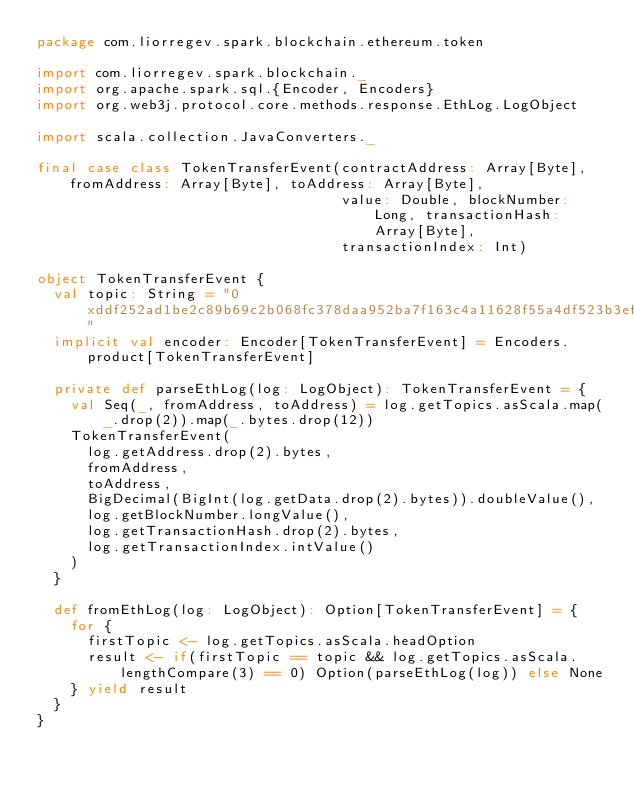<code> <loc_0><loc_0><loc_500><loc_500><_Scala_>package com.liorregev.spark.blockchain.ethereum.token

import com.liorregev.spark.blockchain._
import org.apache.spark.sql.{Encoder, Encoders}
import org.web3j.protocol.core.methods.response.EthLog.LogObject

import scala.collection.JavaConverters._

final case class TokenTransferEvent(contractAddress: Array[Byte], fromAddress: Array[Byte], toAddress: Array[Byte],
                                    value: Double, blockNumber: Long, transactionHash: Array[Byte],
                                    transactionIndex: Int)

object TokenTransferEvent {
  val topic: String = "0xddf252ad1be2c89b69c2b068fc378daa952ba7f163c4a11628f55a4df523b3ef"
  implicit val encoder: Encoder[TokenTransferEvent] = Encoders.product[TokenTransferEvent]

  private def parseEthLog(log: LogObject): TokenTransferEvent = {
    val Seq(_, fromAddress, toAddress) = log.getTopics.asScala.map(_.drop(2)).map(_.bytes.drop(12))
    TokenTransferEvent(
      log.getAddress.drop(2).bytes,
      fromAddress,
      toAddress,
      BigDecimal(BigInt(log.getData.drop(2).bytes)).doubleValue(),
      log.getBlockNumber.longValue(),
      log.getTransactionHash.drop(2).bytes,
      log.getTransactionIndex.intValue()
    )
  }

  def fromEthLog(log: LogObject): Option[TokenTransferEvent] = {
    for {
      firstTopic <- log.getTopics.asScala.headOption
      result <- if(firstTopic == topic && log.getTopics.asScala.lengthCompare(3) == 0) Option(parseEthLog(log)) else None
    } yield result
  }
}
</code> 